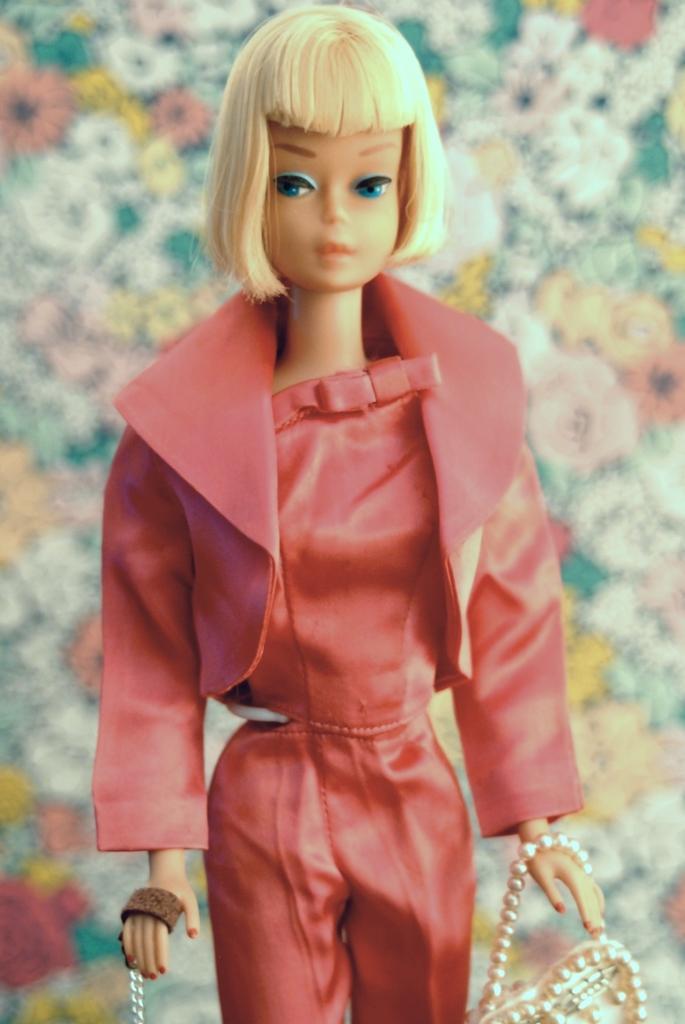Describe this image in one or two sentences. In this image there is doll, the doll is wearing red color jacket, red color pant and to the right hand there is a hand bag and to the left hand there is chain. 